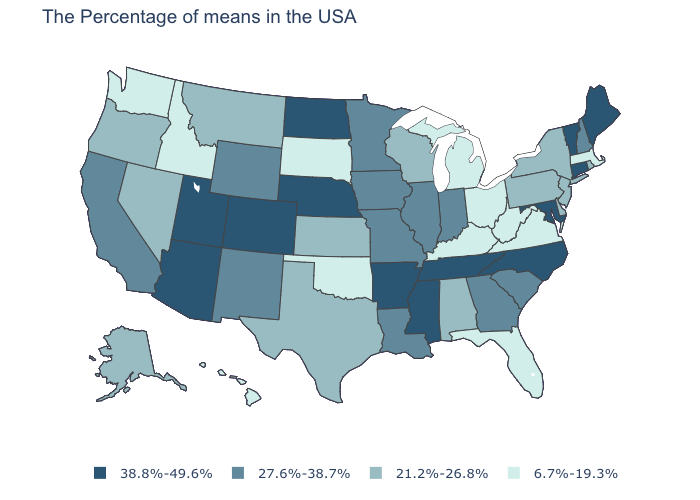Name the states that have a value in the range 27.6%-38.7%?
Keep it brief. New Hampshire, South Carolina, Georgia, Indiana, Illinois, Louisiana, Missouri, Minnesota, Iowa, Wyoming, New Mexico, California. Which states have the highest value in the USA?
Short answer required. Maine, Vermont, Connecticut, Maryland, North Carolina, Tennessee, Mississippi, Arkansas, Nebraska, North Dakota, Colorado, Utah, Arizona. Does the first symbol in the legend represent the smallest category?
Give a very brief answer. No. What is the value of Virginia?
Short answer required. 6.7%-19.3%. What is the highest value in the USA?
Concise answer only. 38.8%-49.6%. How many symbols are there in the legend?
Quick response, please. 4. What is the highest value in the Northeast ?
Write a very short answer. 38.8%-49.6%. Among the states that border Nebraska , does Iowa have the highest value?
Give a very brief answer. No. What is the value of South Carolina?
Give a very brief answer. 27.6%-38.7%. What is the lowest value in the USA?
Short answer required. 6.7%-19.3%. Name the states that have a value in the range 6.7%-19.3%?
Give a very brief answer. Massachusetts, Virginia, West Virginia, Ohio, Florida, Michigan, Kentucky, Oklahoma, South Dakota, Idaho, Washington, Hawaii. Is the legend a continuous bar?
Keep it brief. No. What is the value of Idaho?
Keep it brief. 6.7%-19.3%. What is the value of Georgia?
Answer briefly. 27.6%-38.7%. Does Minnesota have the lowest value in the USA?
Answer briefly. No. 